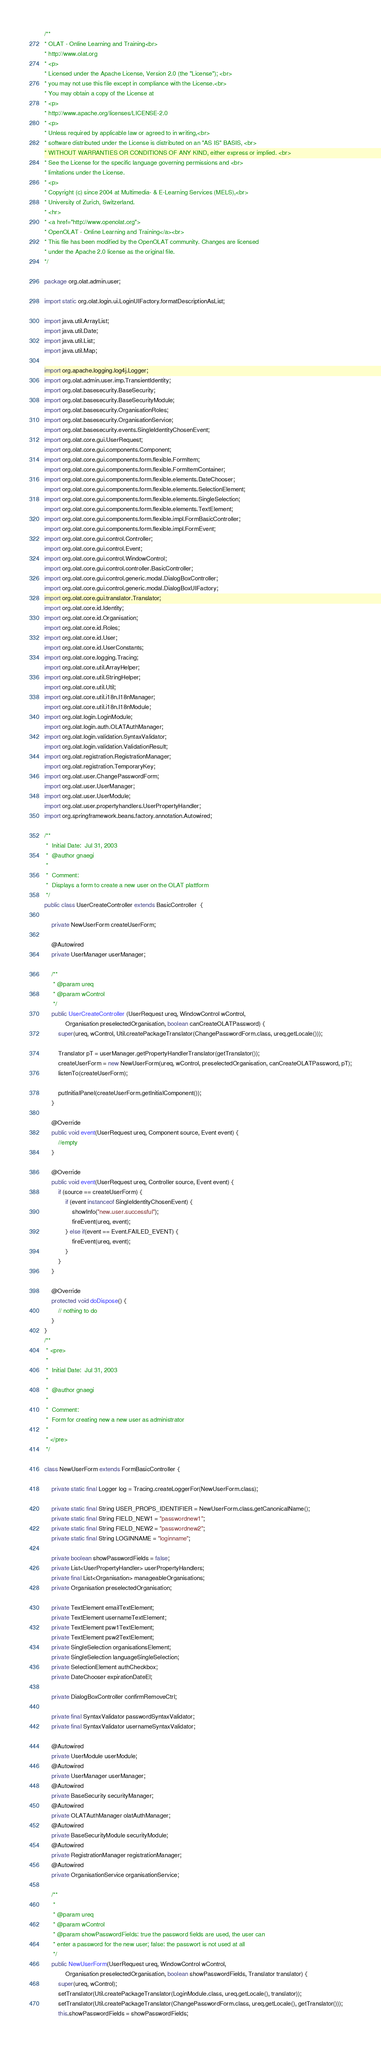Convert code to text. <code><loc_0><loc_0><loc_500><loc_500><_Java_>/**
* OLAT - Online Learning and Training<br>
* http://www.olat.org
* <p>
* Licensed under the Apache License, Version 2.0 (the "License"); <br>
* you may not use this file except in compliance with the License.<br>
* You may obtain a copy of the License at
* <p>
* http://www.apache.org/licenses/LICENSE-2.0
* <p>
* Unless required by applicable law or agreed to in writing,<br>
* software distributed under the License is distributed on an "AS IS" BASIS, <br>
* WITHOUT WARRANTIES OR CONDITIONS OF ANY KIND, either express or implied. <br>
* See the License for the specific language governing permissions and <br>
* limitations under the License.
* <p>
* Copyright (c) since 2004 at Multimedia- & E-Learning Services (MELS),<br>
* University of Zurich, Switzerland.
* <hr>
* <a href="http://www.openolat.org">
* OpenOLAT - Online Learning and Training</a><br>
* This file has been modified by the OpenOLAT community. Changes are licensed
* under the Apache 2.0 license as the original file.
*/

package org.olat.admin.user;

import static org.olat.login.ui.LoginUIFactory.formatDescriptionAsList;

import java.util.ArrayList;
import java.util.Date;
import java.util.List;
import java.util.Map;

import org.apache.logging.log4j.Logger;
import org.olat.admin.user.imp.TransientIdentity;
import org.olat.basesecurity.BaseSecurity;
import org.olat.basesecurity.BaseSecurityModule;
import org.olat.basesecurity.OrganisationRoles;
import org.olat.basesecurity.OrganisationService;
import org.olat.basesecurity.events.SingleIdentityChosenEvent;
import org.olat.core.gui.UserRequest;
import org.olat.core.gui.components.Component;
import org.olat.core.gui.components.form.flexible.FormItem;
import org.olat.core.gui.components.form.flexible.FormItemContainer;
import org.olat.core.gui.components.form.flexible.elements.DateChooser;
import org.olat.core.gui.components.form.flexible.elements.SelectionElement;
import org.olat.core.gui.components.form.flexible.elements.SingleSelection;
import org.olat.core.gui.components.form.flexible.elements.TextElement;
import org.olat.core.gui.components.form.flexible.impl.FormBasicController;
import org.olat.core.gui.components.form.flexible.impl.FormEvent;
import org.olat.core.gui.control.Controller;
import org.olat.core.gui.control.Event;
import org.olat.core.gui.control.WindowControl;
import org.olat.core.gui.control.controller.BasicController;
import org.olat.core.gui.control.generic.modal.DialogBoxController;
import org.olat.core.gui.control.generic.modal.DialogBoxUIFactory;
import org.olat.core.gui.translator.Translator;
import org.olat.core.id.Identity;
import org.olat.core.id.Organisation;
import org.olat.core.id.Roles;
import org.olat.core.id.User;
import org.olat.core.id.UserConstants;
import org.olat.core.logging.Tracing;
import org.olat.core.util.ArrayHelper;
import org.olat.core.util.StringHelper;
import org.olat.core.util.Util;
import org.olat.core.util.i18n.I18nManager;
import org.olat.core.util.i18n.I18nModule;
import org.olat.login.LoginModule;
import org.olat.login.auth.OLATAuthManager;
import org.olat.login.validation.SyntaxValidator;
import org.olat.login.validation.ValidationResult;
import org.olat.registration.RegistrationManager;
import org.olat.registration.TemporaryKey;
import org.olat.user.ChangePasswordForm;
import org.olat.user.UserManager;
import org.olat.user.UserModule;
import org.olat.user.propertyhandlers.UserPropertyHandler;
import org.springframework.beans.factory.annotation.Autowired;

/**
 *  Initial Date:  Jul 31, 2003
 *  @author gnaegi
 *  
 *  Comment:  
 *  Displays a form to create a new user on the OLAT plattform
 */
public class UserCreateController extends BasicController  {

	private NewUserForm createUserForm;
	
	@Autowired
	private UserManager userManager;
	
	/**
	 * @param ureq
	 * @param wControl
	 */
	public UserCreateController (UserRequest ureq, WindowControl wControl,
			Organisation preselectedOrganisation, boolean canCreateOLATPassword) {
		super(ureq, wControl, Util.createPackageTranslator(ChangePasswordForm.class, ureq.getLocale()));
		
		Translator pT = userManager.getPropertyHandlerTranslator(getTranslator());
		createUserForm = new NewUserForm(ureq, wControl, preselectedOrganisation, canCreateOLATPassword, pT);
		listenTo(createUserForm);

		putInitialPanel(createUserForm.getInitialComponent());
	}

	@Override
	public void event(UserRequest ureq, Component source, Event event) {
		//empty
	}

	@Override
	public void event(UserRequest ureq, Controller source, Event event) {
		if (source == createUserForm) {
			if (event instanceof SingleIdentityChosenEvent) {
				showInfo("new.user.successful");
				fireEvent(ureq, event);
			} else if(event == Event.FAILED_EVENT) {
				fireEvent(ureq, event);
			}
		}
	}	

	@Override
	protected void doDispose() {
		// nothing to do
	}
}
/**
 * <pre>
 * 
 *  Initial Date:  Jul 31, 2003
 * 
 *  @author gnaegi
 *  
 *  Comment:  
 *  Form for creating new a new user as administrator
 *  
 * </pre>
 */

class NewUserForm extends FormBasicController {
	
	private static final Logger log = Tracing.createLoggerFor(NewUserForm.class);
	
	private static final String USER_PROPS_IDENTIFIER = NewUserForm.class.getCanonicalName();
	private static final String FIELD_NEW1 = "passwordnew1";
	private static final String FIELD_NEW2 = "passwordnew2";
	private static final String LOGINNAME = "loginname";

	private boolean showPasswordFields = false;
	private List<UserPropertyHandler> userPropertyHandlers;
	private final List<Organisation> manageableOrganisations;
	private Organisation preselectedOrganisation;
	
	private TextElement emailTextElement;
	private TextElement usernameTextElement;
	private TextElement psw1TextElement;
	private TextElement psw2TextElement;
	private SingleSelection organisationsElement;
	private SingleSelection languageSingleSelection;
	private SelectionElement authCheckbox;
	private DateChooser expirationDateEl;
	
	private DialogBoxController confirmRemoveCtrl;

	private final SyntaxValidator passwordSyntaxValidator;
	private final SyntaxValidator usernameSyntaxValidator;
	
	@Autowired
	private UserModule userModule;
	@Autowired
	private UserManager userManager;
	@Autowired
	private BaseSecurity securityManager;
	@Autowired
	private OLATAuthManager olatAuthManager;
	@Autowired
	private BaseSecurityModule securityModule;
	@Autowired
	private RegistrationManager registrationManager;
	@Autowired
	private OrganisationService organisationService;

	/**
	 * 
	 * @param ureq
	 * @param wControl
	 * @param showPasswordFields: true the password fields are used, the user can 
	 * enter a password for the new user; false: the passwort is not used at all
	 */
	public NewUserForm(UserRequest ureq, WindowControl wControl,
			Organisation preselectedOrganisation, boolean showPasswordFields, Translator translator) {
		super(ureq, wControl);
		setTranslator(Util.createPackageTranslator(LoginModule.class, ureq.getLocale(), translator));
		setTranslator(Util.createPackageTranslator(ChangePasswordForm.class, ureq.getLocale(), getTranslator()));
		this.showPasswordFields = showPasswordFields;</code> 